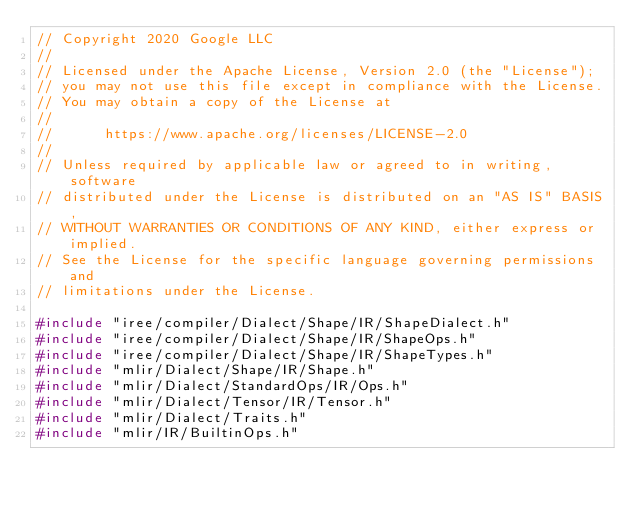<code> <loc_0><loc_0><loc_500><loc_500><_C++_>// Copyright 2020 Google LLC
//
// Licensed under the Apache License, Version 2.0 (the "License");
// you may not use this file except in compliance with the License.
// You may obtain a copy of the License at
//
//      https://www.apache.org/licenses/LICENSE-2.0
//
// Unless required by applicable law or agreed to in writing, software
// distributed under the License is distributed on an "AS IS" BASIS,
// WITHOUT WARRANTIES OR CONDITIONS OF ANY KIND, either express or implied.
// See the License for the specific language governing permissions and
// limitations under the License.

#include "iree/compiler/Dialect/Shape/IR/ShapeDialect.h"
#include "iree/compiler/Dialect/Shape/IR/ShapeOps.h"
#include "iree/compiler/Dialect/Shape/IR/ShapeTypes.h"
#include "mlir/Dialect/Shape/IR/Shape.h"
#include "mlir/Dialect/StandardOps/IR/Ops.h"
#include "mlir/Dialect/Tensor/IR/Tensor.h"
#include "mlir/Dialect/Traits.h"
#include "mlir/IR/BuiltinOps.h"</code> 